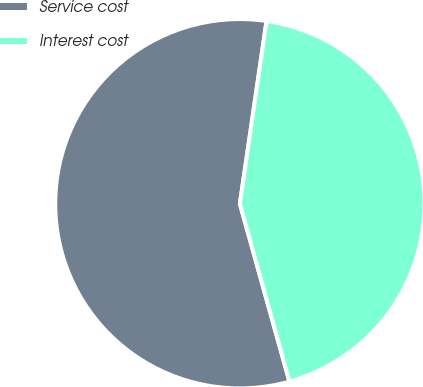Convert chart to OTSL. <chart><loc_0><loc_0><loc_500><loc_500><pie_chart><fcel>Service cost<fcel>Interest cost<nl><fcel>56.63%<fcel>43.37%<nl></chart> 